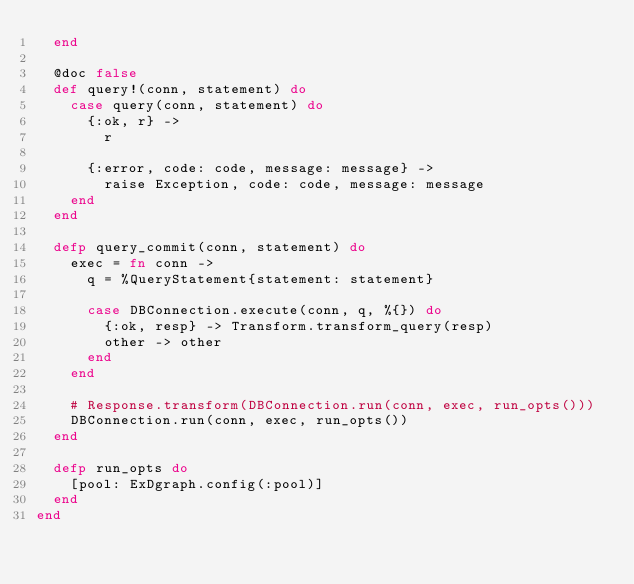Convert code to text. <code><loc_0><loc_0><loc_500><loc_500><_Elixir_>  end

  @doc false
  def query!(conn, statement) do
    case query(conn, statement) do
      {:ok, r} ->
        r

      {:error, code: code, message: message} ->
        raise Exception, code: code, message: message
    end
  end

  defp query_commit(conn, statement) do
    exec = fn conn ->
      q = %QueryStatement{statement: statement}

      case DBConnection.execute(conn, q, %{}) do
        {:ok, resp} -> Transform.transform_query(resp)
        other -> other
      end
    end

    # Response.transform(DBConnection.run(conn, exec, run_opts()))
    DBConnection.run(conn, exec, run_opts())
  end

  defp run_opts do
    [pool: ExDgraph.config(:pool)]
  end
end
</code> 